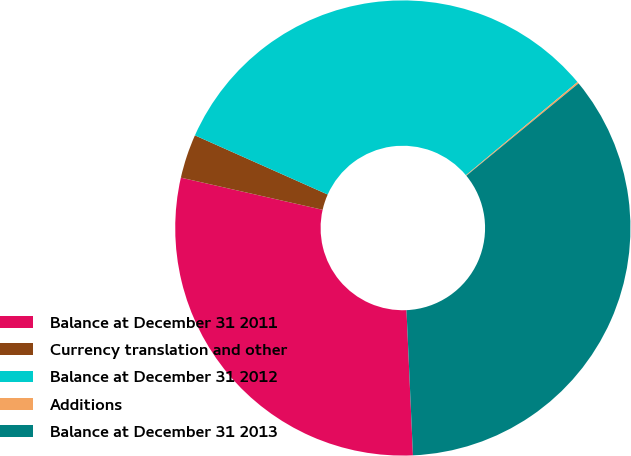Convert chart to OTSL. <chart><loc_0><loc_0><loc_500><loc_500><pie_chart><fcel>Balance at December 31 2011<fcel>Currency translation and other<fcel>Balance at December 31 2012<fcel>Additions<fcel>Balance at December 31 2013<nl><fcel>29.26%<fcel>3.12%<fcel>32.25%<fcel>0.12%<fcel>35.25%<nl></chart> 